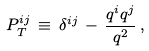<formula> <loc_0><loc_0><loc_500><loc_500>P _ { T } ^ { i j } \, \equiv \, \delta ^ { i j } \, - \, \frac { q ^ { i } q ^ { j } } { { q } ^ { 2 } } \, ,</formula> 